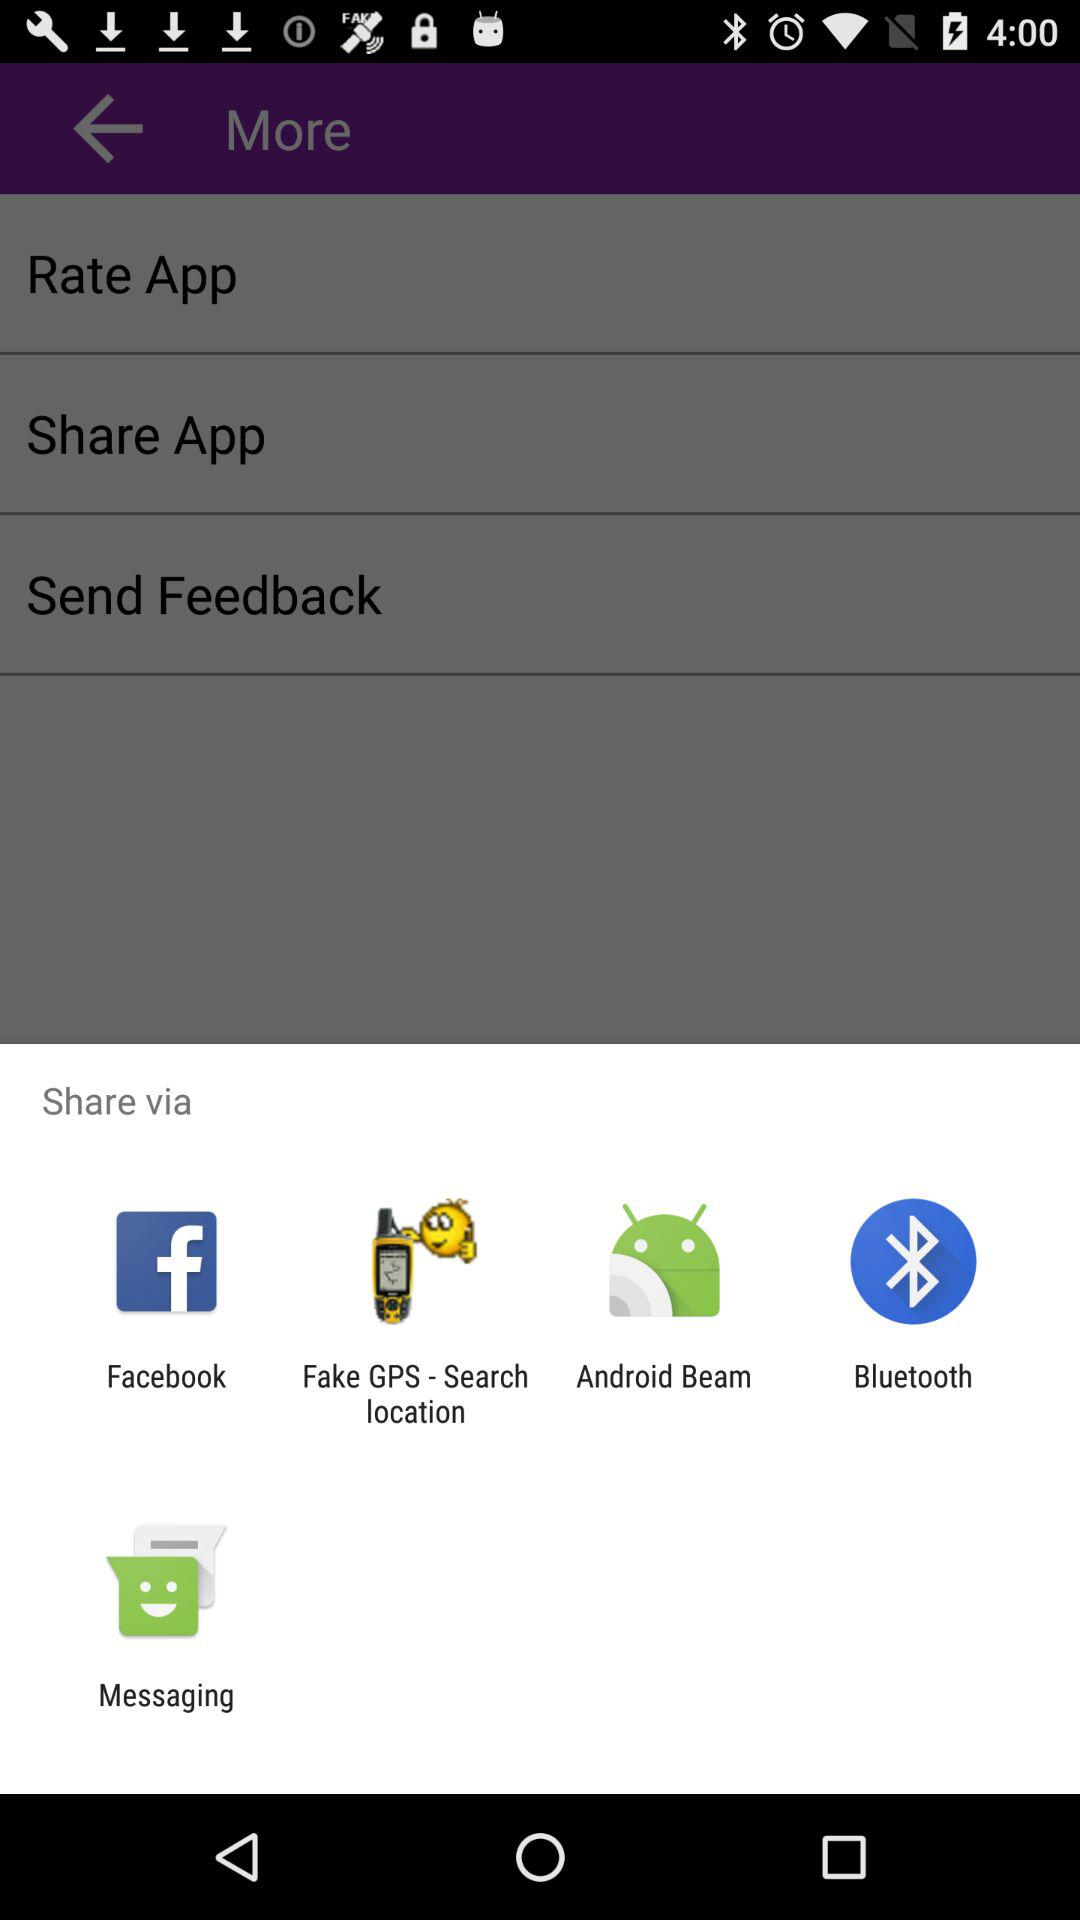What are the apps that can be used to share the content? The apps that can be used to share the content are "Facebook", "Fake GPS - Search location", "Android Beam", "Bluetooth" and "Messaging". 